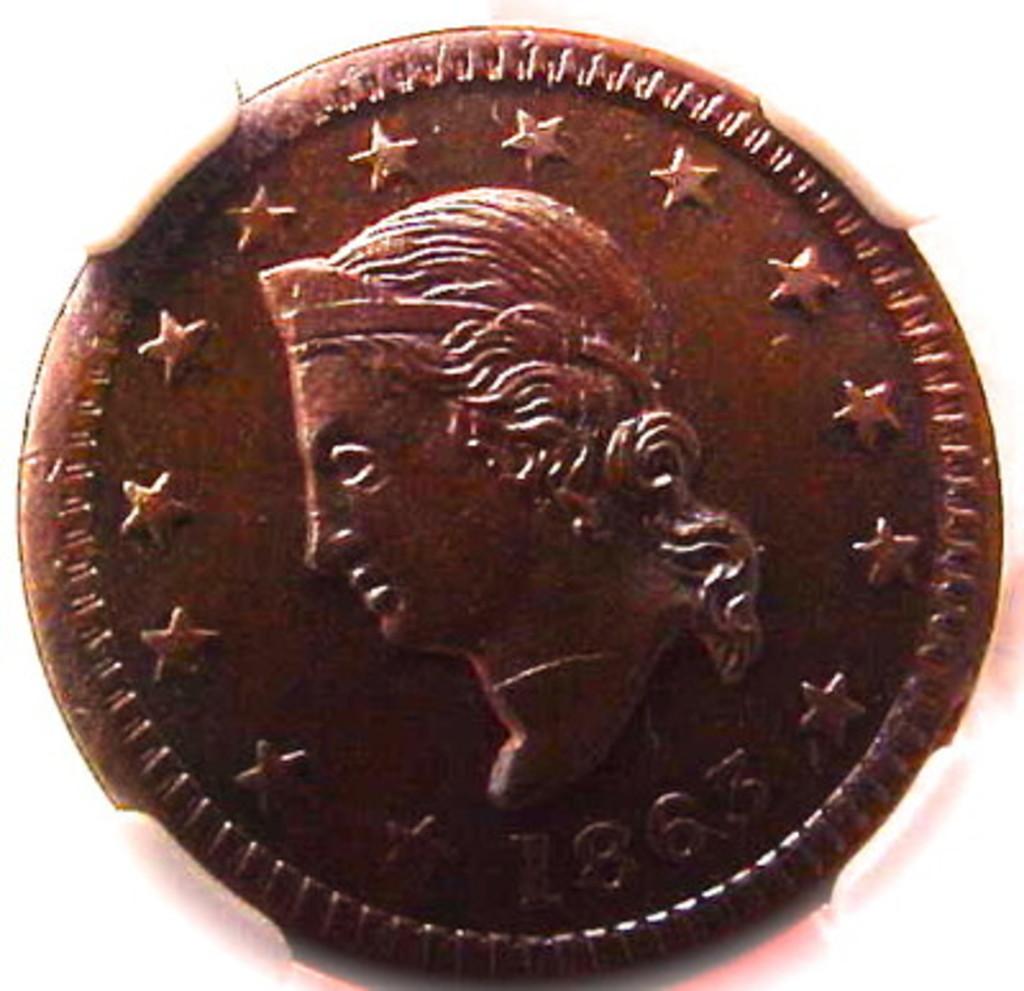What is the year on this old coin?
Give a very brief answer. 1863. 